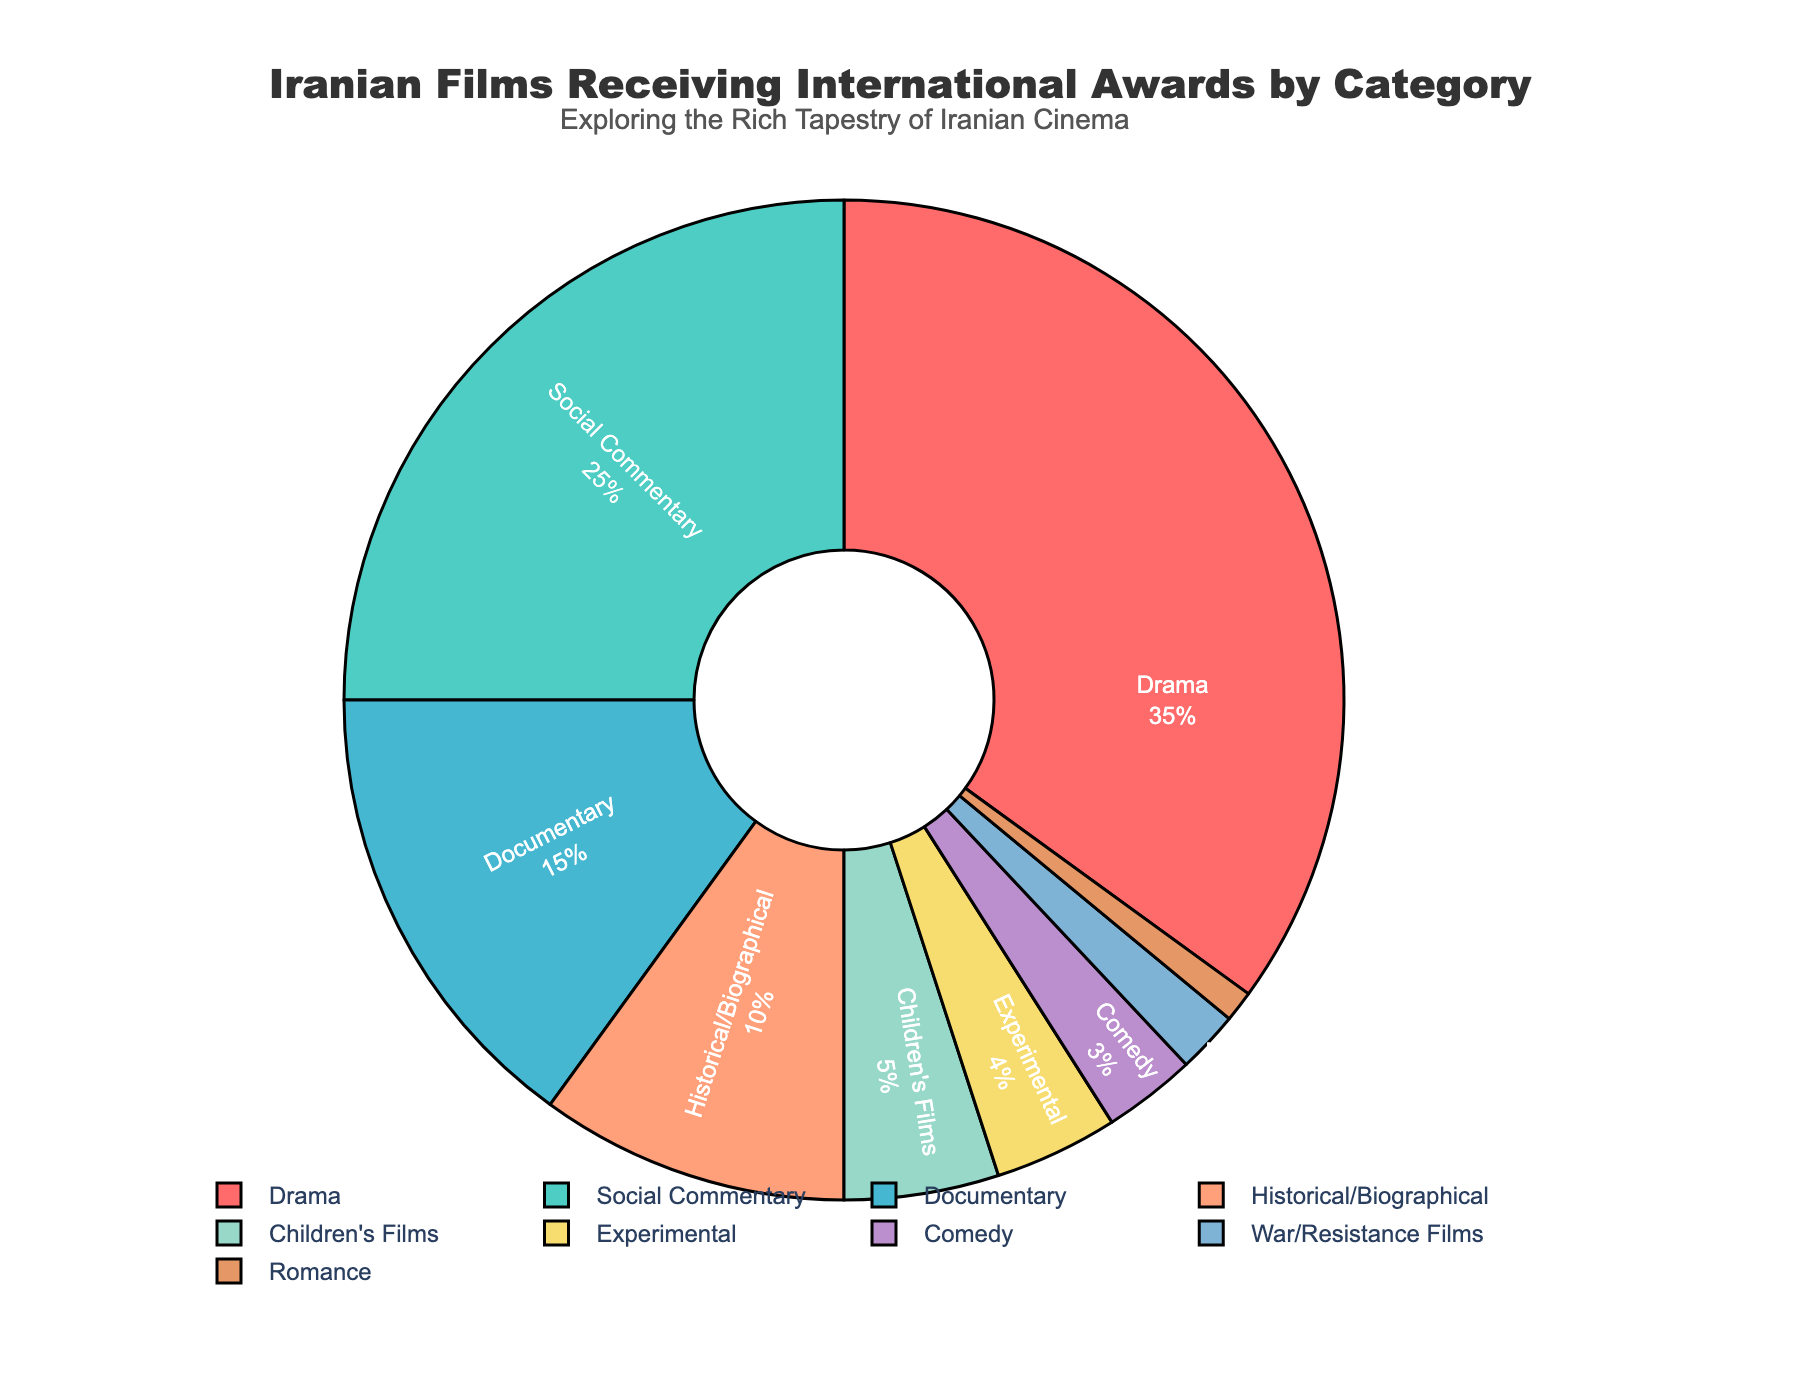What category has the highest percentage of Iranian films receiving international awards? By observing the chart, the category with the largest portion is easily identified by its area and percentage label. The chart shows that Drama has the largest segment labeled as 35%.
Answer: Drama Which categories combined make up more than 50% of the awards? To find which combined categories exceed 50%, add the respective percentages: Drama (35%) + Social Commentary (25%) = 60%, which exceeds 50%.
Answer: Drama, Social Commentary How does the percentage of Children's Films compare to that of Experimental films? By looking at the chart, compare the slices with their respective labels: Children's Films (5%) and Experimental (4%). 5% is slightly more than 4%.
Answer: Children’s Films have a higher percentage What is the combined percentage of War/Resistance Films and Romance films? Add the percentages of War/Resistance Films (2%) and Romance (1%) to find the combined value: 2% + 1% = 3%.
Answer: 3% How many percentage points higher is the Documentary category than the Comedy category? Subtract the Comedy percentage from the Documentary percentage: 15% – 3% = 12%.
Answer: 12% Compare the total percentage of top three categories to the next two categories. Which group is larger? Sum the top three categories: Drama (35%) + Social Commentary (25%) + Documentary (15%) = 75%. Sum the next two: Historical/Biographical (10%) + Children's Films (5%) = 15%. The top three categories combined (75%) is much larger than the next two categories combined (15%).
Answer: Top three categories What is the smallest category in terms of percentage and what practical implication might this have? The smallest segment is noted by its area and percentage label: Romance with 1%. A practical implication could be that Iranian romance films receive less international recognition.
Answer: Romance 